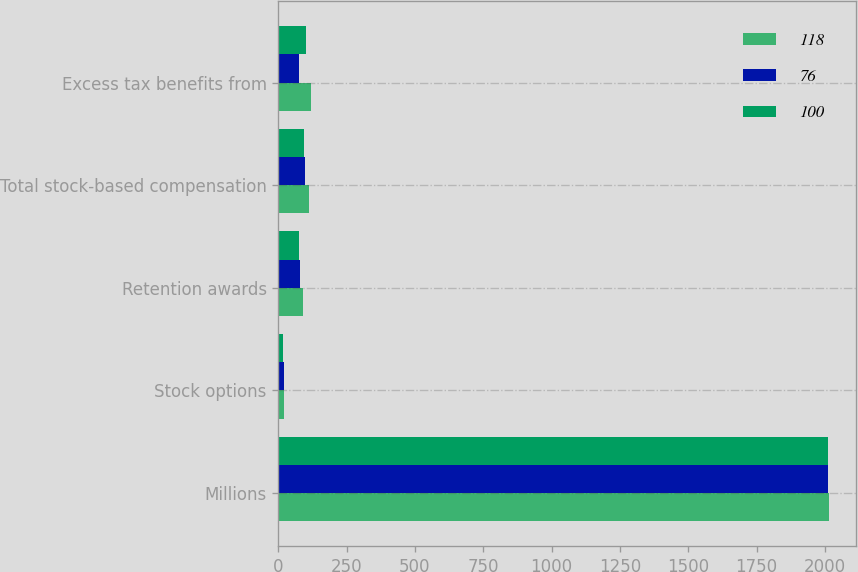Convert chart to OTSL. <chart><loc_0><loc_0><loc_500><loc_500><stacked_bar_chart><ecel><fcel>Millions<fcel>Stock options<fcel>Retention awards<fcel>Total stock-based compensation<fcel>Excess tax benefits from<nl><fcel>118<fcel>2014<fcel>21<fcel>91<fcel>112<fcel>118<nl><fcel>76<fcel>2013<fcel>19<fcel>79<fcel>98<fcel>76<nl><fcel>100<fcel>2012<fcel>18<fcel>75<fcel>93<fcel>100<nl></chart> 